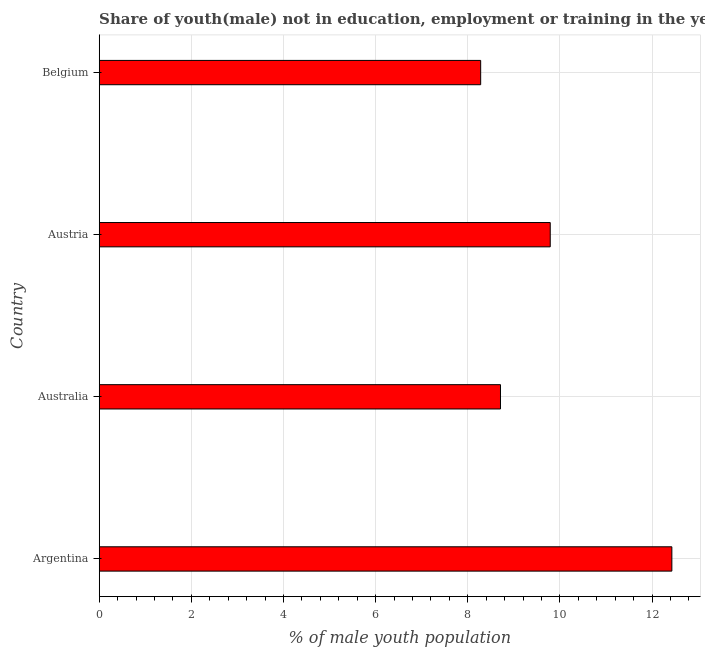What is the title of the graph?
Provide a succinct answer. Share of youth(male) not in education, employment or training in the year 2004. What is the label or title of the X-axis?
Make the answer very short. % of male youth population. What is the label or title of the Y-axis?
Provide a succinct answer. Country. What is the unemployed male youth population in Austria?
Your response must be concise. 9.79. Across all countries, what is the maximum unemployed male youth population?
Your answer should be very brief. 12.43. Across all countries, what is the minimum unemployed male youth population?
Ensure brevity in your answer.  8.28. In which country was the unemployed male youth population maximum?
Offer a terse response. Argentina. In which country was the unemployed male youth population minimum?
Offer a very short reply. Belgium. What is the sum of the unemployed male youth population?
Your answer should be compact. 39.21. What is the difference between the unemployed male youth population in Argentina and Belgium?
Ensure brevity in your answer.  4.15. What is the average unemployed male youth population per country?
Give a very brief answer. 9.8. What is the median unemployed male youth population?
Give a very brief answer. 9.25. What is the ratio of the unemployed male youth population in Argentina to that in Australia?
Ensure brevity in your answer.  1.43. Is the unemployed male youth population in Austria less than that in Belgium?
Provide a short and direct response. No. Is the difference between the unemployed male youth population in Argentina and Austria greater than the difference between any two countries?
Offer a very short reply. No. What is the difference between the highest and the second highest unemployed male youth population?
Your response must be concise. 2.64. Is the sum of the unemployed male youth population in Australia and Belgium greater than the maximum unemployed male youth population across all countries?
Provide a short and direct response. Yes. What is the difference between the highest and the lowest unemployed male youth population?
Your answer should be compact. 4.15. In how many countries, is the unemployed male youth population greater than the average unemployed male youth population taken over all countries?
Keep it short and to the point. 1. Are all the bars in the graph horizontal?
Make the answer very short. Yes. What is the difference between two consecutive major ticks on the X-axis?
Keep it short and to the point. 2. Are the values on the major ticks of X-axis written in scientific E-notation?
Provide a succinct answer. No. What is the % of male youth population in Argentina?
Your answer should be very brief. 12.43. What is the % of male youth population of Australia?
Provide a succinct answer. 8.71. What is the % of male youth population in Austria?
Make the answer very short. 9.79. What is the % of male youth population in Belgium?
Your response must be concise. 8.28. What is the difference between the % of male youth population in Argentina and Australia?
Your answer should be compact. 3.72. What is the difference between the % of male youth population in Argentina and Austria?
Ensure brevity in your answer.  2.64. What is the difference between the % of male youth population in Argentina and Belgium?
Keep it short and to the point. 4.15. What is the difference between the % of male youth population in Australia and Austria?
Offer a terse response. -1.08. What is the difference between the % of male youth population in Australia and Belgium?
Your answer should be compact. 0.43. What is the difference between the % of male youth population in Austria and Belgium?
Make the answer very short. 1.51. What is the ratio of the % of male youth population in Argentina to that in Australia?
Offer a very short reply. 1.43. What is the ratio of the % of male youth population in Argentina to that in Austria?
Your response must be concise. 1.27. What is the ratio of the % of male youth population in Argentina to that in Belgium?
Your answer should be compact. 1.5. What is the ratio of the % of male youth population in Australia to that in Austria?
Keep it short and to the point. 0.89. What is the ratio of the % of male youth population in Australia to that in Belgium?
Offer a terse response. 1.05. What is the ratio of the % of male youth population in Austria to that in Belgium?
Provide a short and direct response. 1.18. 